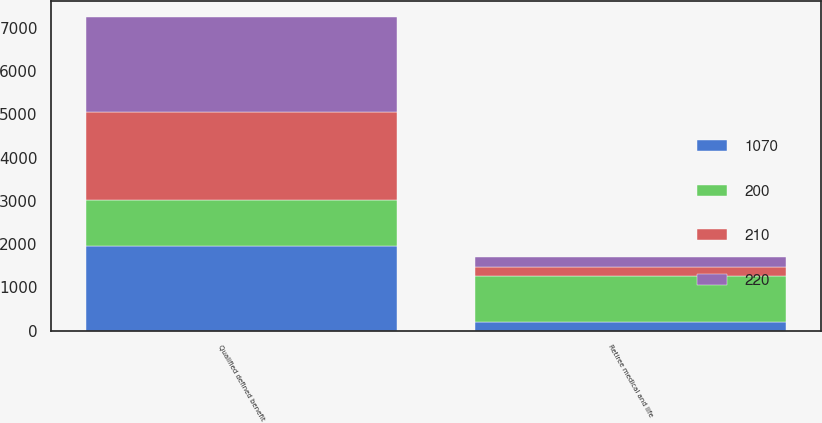Convert chart to OTSL. <chart><loc_0><loc_0><loc_500><loc_500><stacked_bar_chart><ecel><fcel>Qualified defined benefit<fcel>Retiree medical and life<nl><fcel>1070<fcel>1960<fcel>200<nl><fcel>210<fcel>2030<fcel>210<nl><fcel>220<fcel>2200<fcel>220<nl><fcel>200<fcel>1070<fcel>1070<nl></chart> 